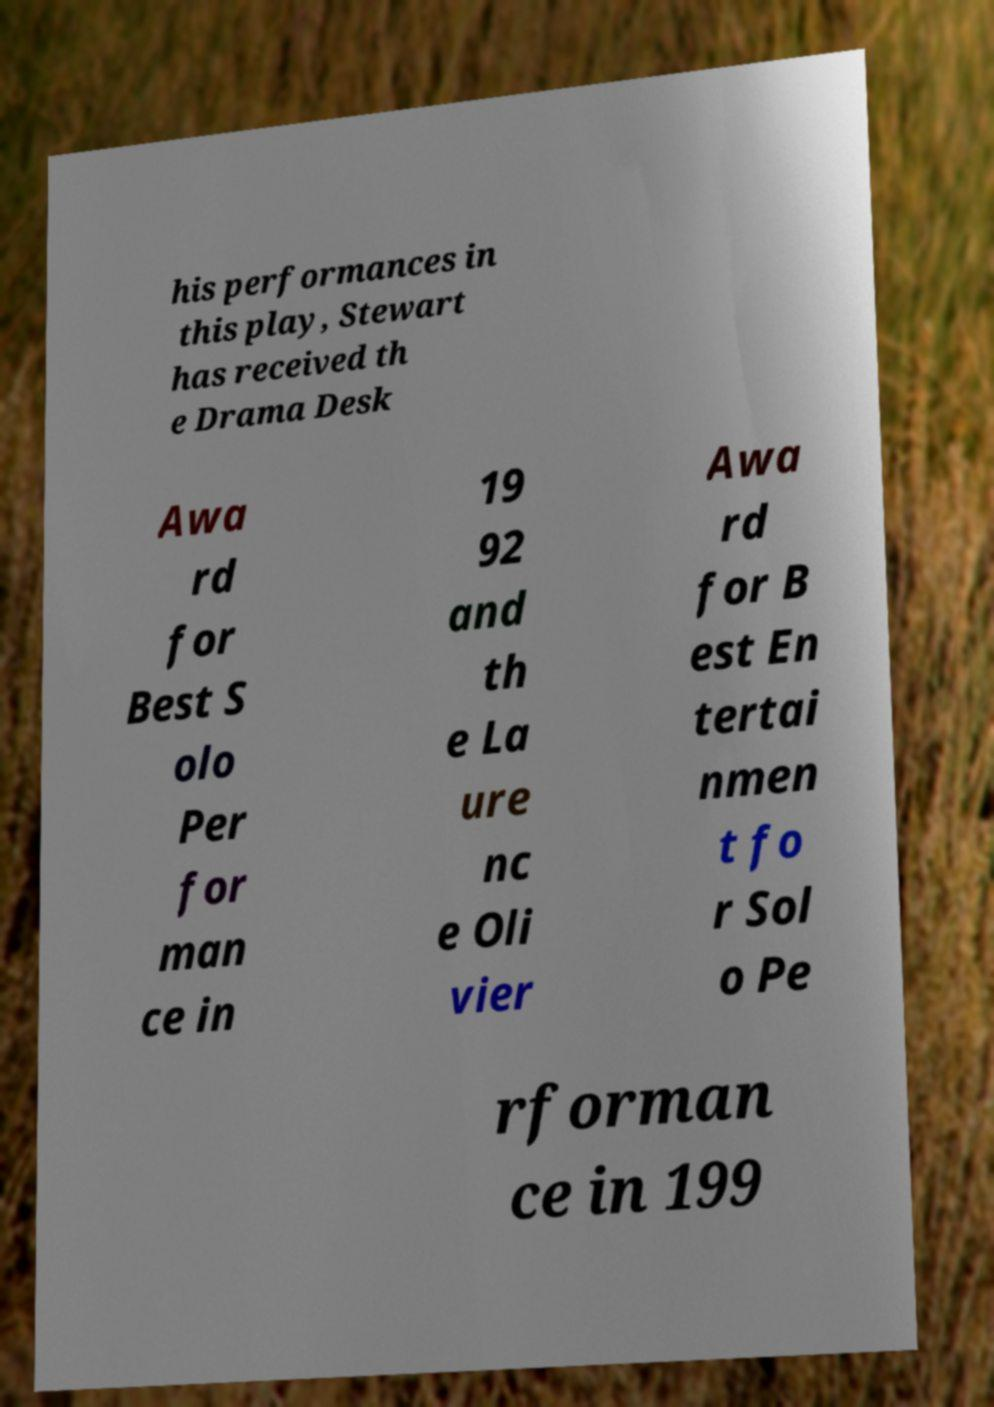I need the written content from this picture converted into text. Can you do that? his performances in this play, Stewart has received th e Drama Desk Awa rd for Best S olo Per for man ce in 19 92 and th e La ure nc e Oli vier Awa rd for B est En tertai nmen t fo r Sol o Pe rforman ce in 199 